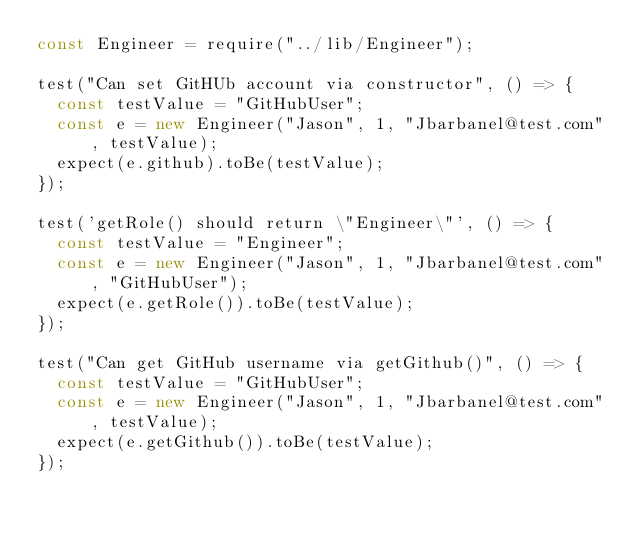<code> <loc_0><loc_0><loc_500><loc_500><_JavaScript_>const Engineer = require("../lib/Engineer");

test("Can set GitHUb account via constructor", () => {
  const testValue = "GitHubUser";
  const e = new Engineer("Jason", 1, "Jbarbanel@test.com", testValue);
  expect(e.github).toBe(testValue);
});

test('getRole() should return \"Engineer\"', () => {
  const testValue = "Engineer";
  const e = new Engineer("Jason", 1, "Jbarbanel@test.com", "GitHubUser");
  expect(e.getRole()).toBe(testValue);
});

test("Can get GitHub username via getGithub()", () => {
  const testValue = "GitHubUser";
  const e = new Engineer("Jason", 1, "Jbarbanel@test.com", testValue);
  expect(e.getGithub()).toBe(testValue);
});</code> 